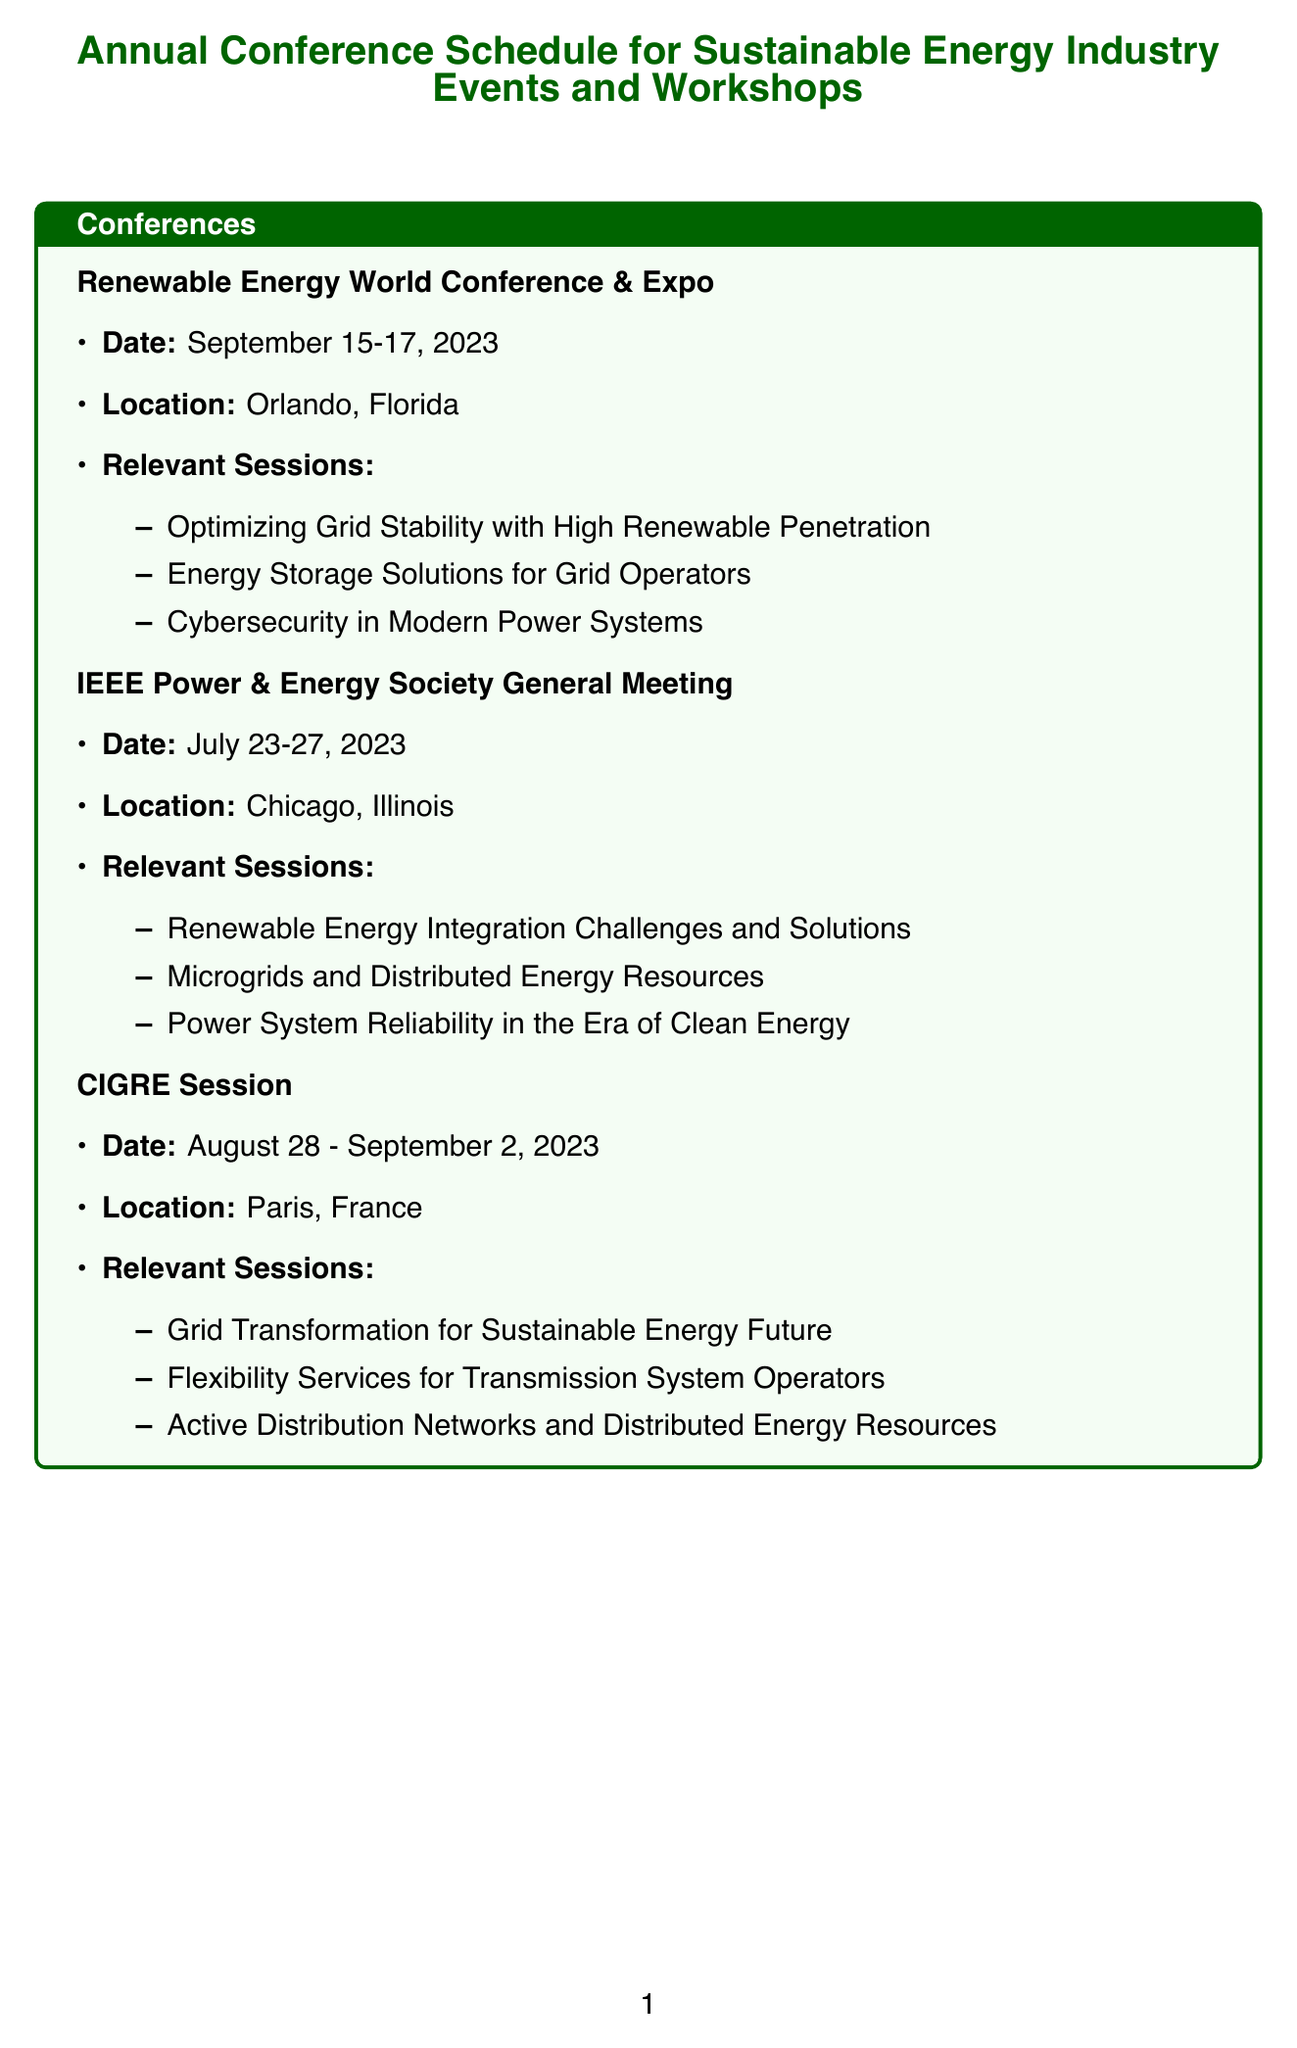what is the date of the Renewable Energy World Conference & Expo? The date is specified in the conference details.
Answer: September 15-17, 2023 where will the IEEE Power & Energy Society General Meeting be held? The location is outlined in the document under the meeting's details.
Answer: Chicago, Illinois what is one of the relevant topics for the Grid Edge Innovation Summit? The document lists several relevant topics under the workshop details.
Answer: Advanced Distribution Management Systems how many relevant sessions are there for the CIGRE Session? The number of sessions is provided in the relevant sessions list for that conference.
Answer: 3 what is the focus of the NERC Reliability Leadership Summit? The focus is described in the workshop's description.
Answer: Maintaining grid reliability while transitioning to cleaner energy sources who is responsible for delivering the EPRI Power Delivery and Utilization Course? The provider of the training is indicated by the name of the course in the document.
Answer: EPRI which workshop is related to energy storage technologies? The workshops section specifies focuses for each event.
Answer: Energy Storage Association Annual Conference what training module includes cybersecurity education? The relevant modules focus on specific topics found in the training details.
Answer: Cybersecurity for Digital Substations in which location is the CIGRE Session taking place? The document provides specific locations for each conference or workshop.
Answer: Paris, France 